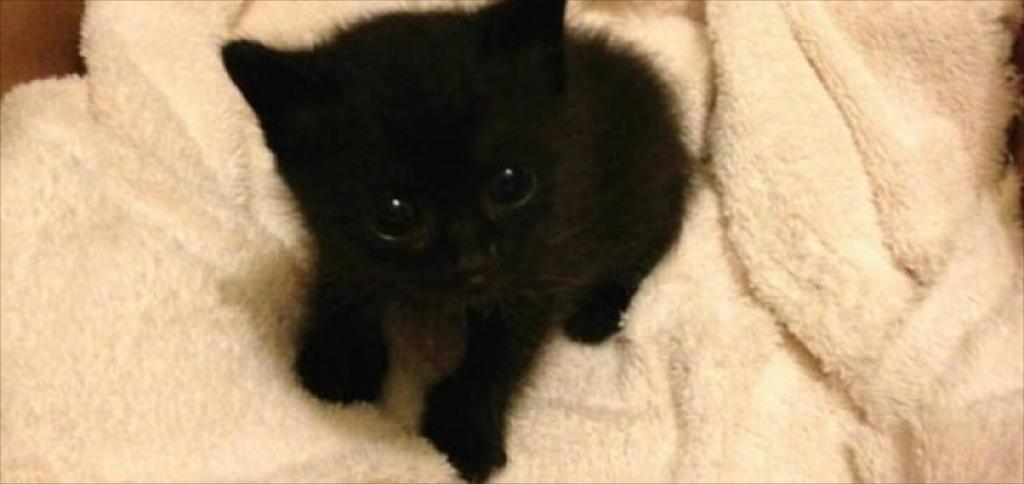What type of creature is present in the image? There is an animal in the image. Can you describe the setting or background of the image? The provided facts do not mention any specific background or setting. However, we know that the animal is on a white cloth. Are there any fairies pulling the animal on the white cloth in the image? There is no mention of fairies or any pulling action in the image. The animal is simply on a white cloth. 